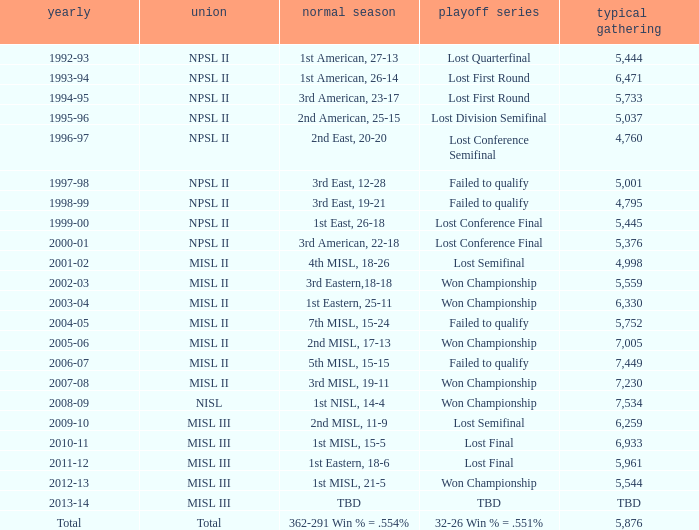In 2010-11, what was the League name? MISL III. 